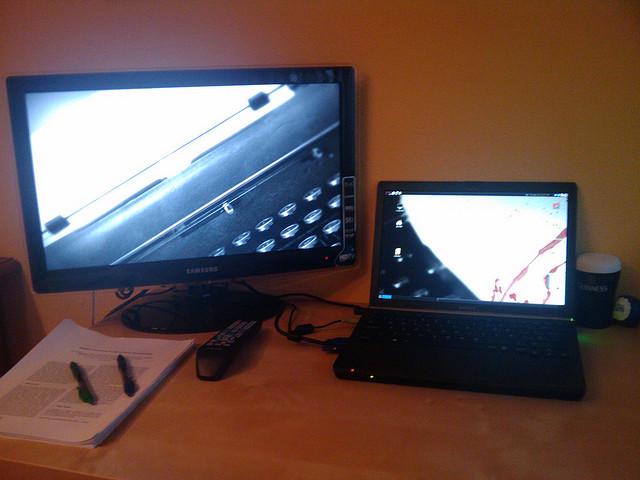How many monitors are there?
Be succinct. 2. What is in front of the desktop computer?
Be succinct. Remote. Do you see any writing utensils on the desk?
Write a very short answer. Yes. Is there anything to read on the desk?
Write a very short answer. Yes. 